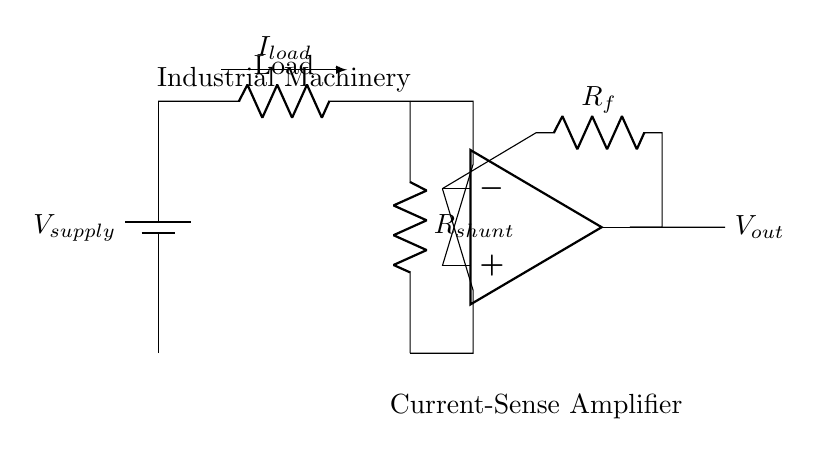What is the supply voltage in this circuit? The supply voltage is marked as V supply, which usually represents the input voltage necessary for the circuit to operate. However, the specific numerical value is not indicated in the circuit diagram shown.
Answer: V supply What component is used for current sensing? The current sensing is performed using the shunt resistor, represented by R shunt in the circuit diagram. The shunt resistor allows current to pass through it while developing a small voltage proportional to the amount of current.
Answer: R shunt What type of operational amplifier configuration is used here? This circuit utilizes a differential amplifier configuration, as the operational amplifier is connected to two inputs for measuring the voltage across the shunt resistor. This configuration amplifies the differential voltage present between its input pins.
Answer: Differential amplifier What is the purpose of the feedback resistor? The feedback resistor, labeled R f in the diagram, is crucial for setting the gain of the operational amplifier. It determines how much of the output voltage is fed back to the inverting input, thus influencing the overall sensitivity and amplification of the current sensing process.
Answer: Set gain What does the output voltage represent? The output voltage, labeled V out, represents the amplified signal that corresponds to the current flowing through the load and the shunt resistor. It reflects the power consumption as sensed by the circuit, allowing users to monitor machinery performance.
Answer: V out How does the direction of current flow affect the output? The direction of the current flow (denoted as I load) indicates that the circuit senses the current flowing through the load. If the load current increases or reverses, the voltage across R shunt changes, thus affecting the output voltage of the operational amplifier directly based on its differential input.
Answer: Affects output 